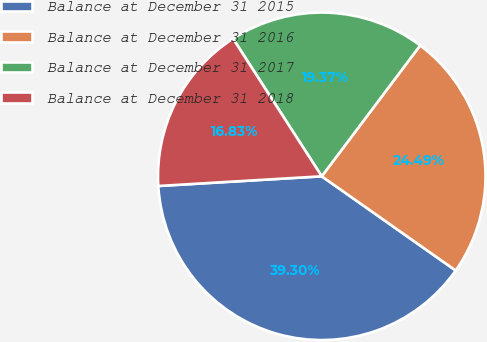Convert chart to OTSL. <chart><loc_0><loc_0><loc_500><loc_500><pie_chart><fcel>Balance at December 31 2015<fcel>Balance at December 31 2016<fcel>Balance at December 31 2017<fcel>Balance at December 31 2018<nl><fcel>39.3%<fcel>24.49%<fcel>19.37%<fcel>16.83%<nl></chart> 